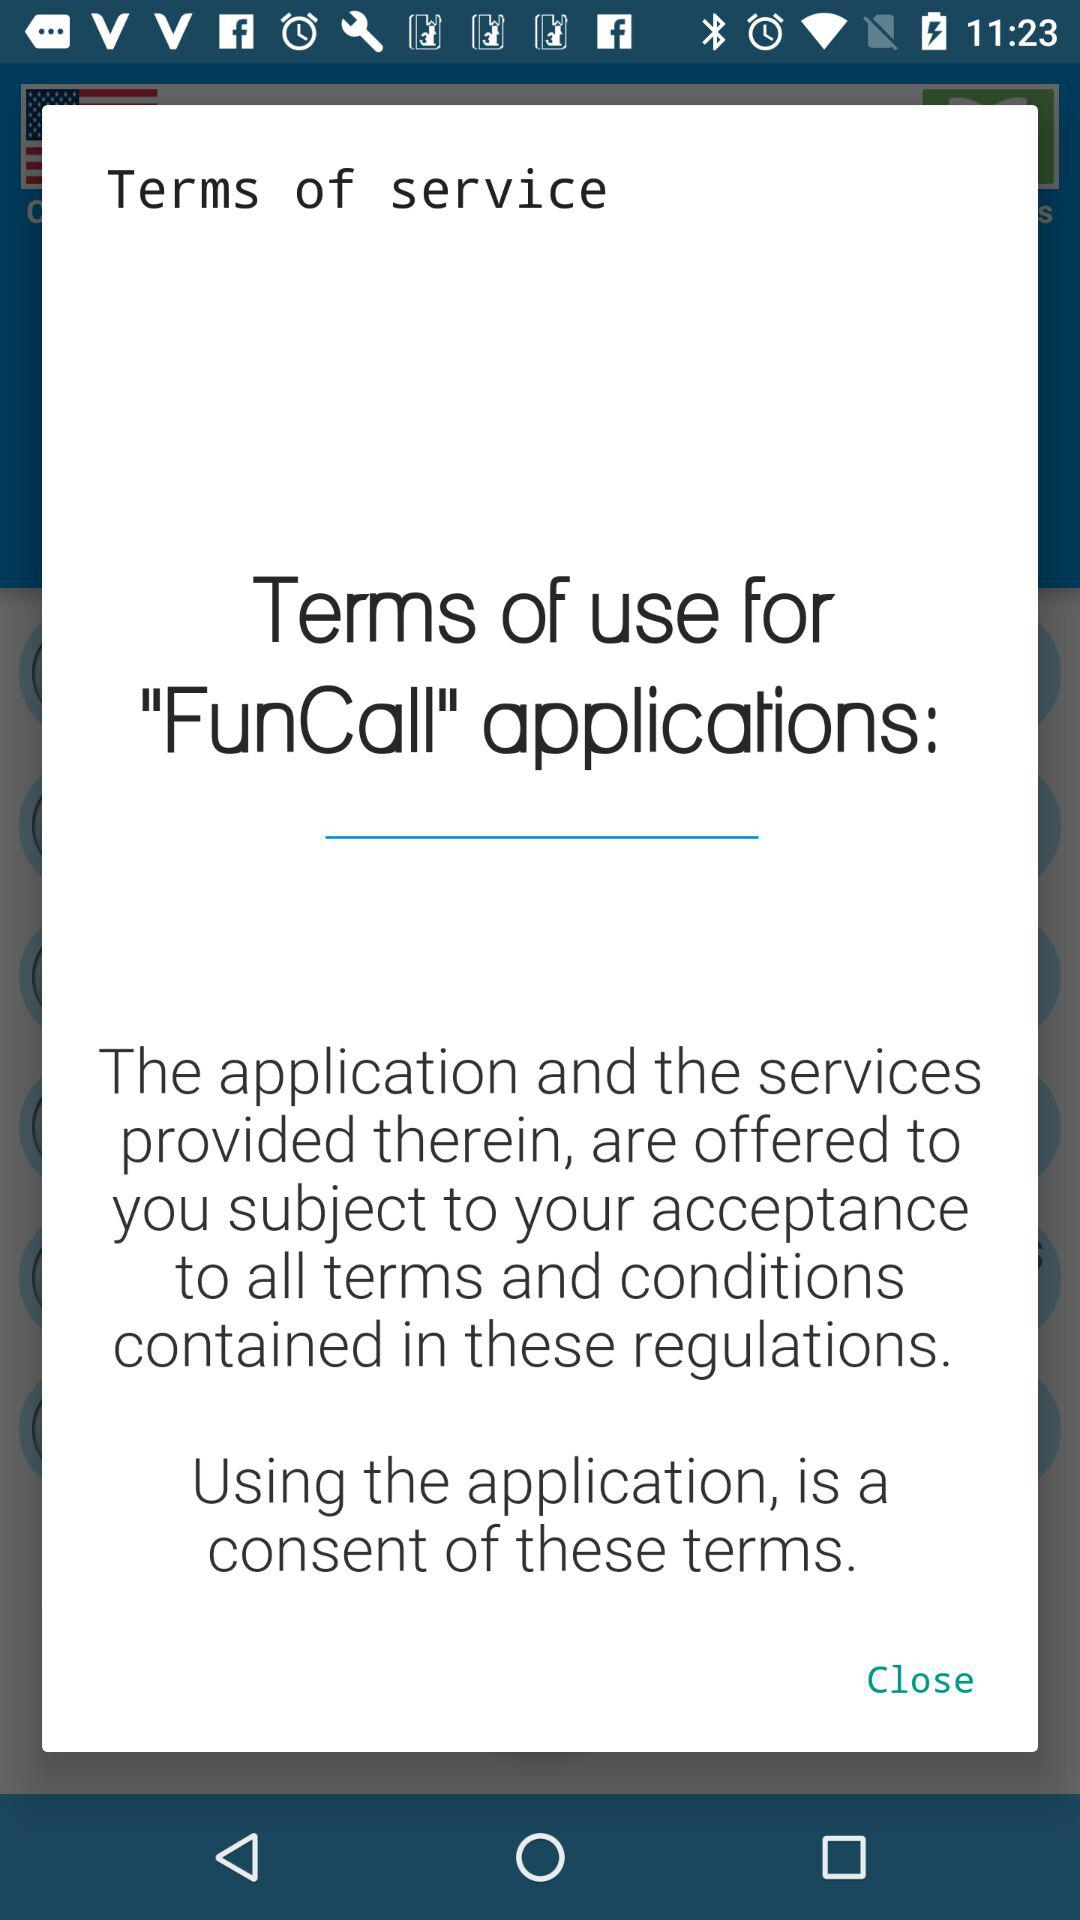What is the application name? The application name is "FunCall". 